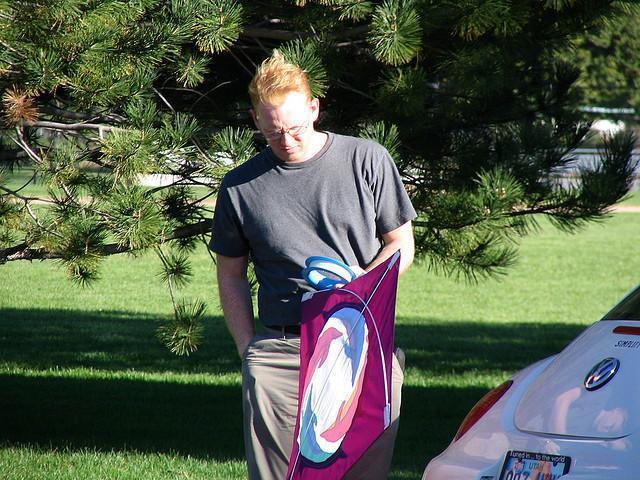How many clock towers are in the town?
Give a very brief answer. 0. 